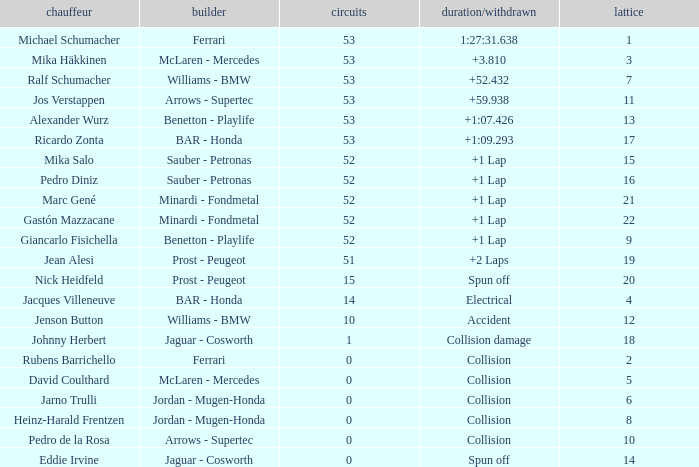What is the name of the driver with a grid less than 14, laps smaller than 53 and a Time/Retired of collision, and a Constructor of ferrari? Rubens Barrichello. 